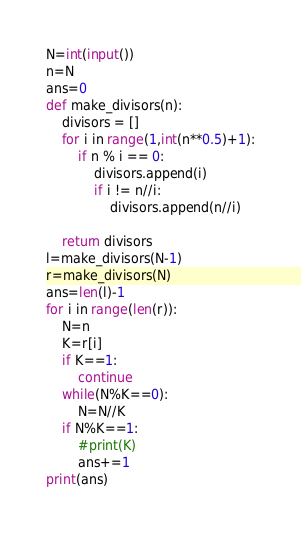Convert code to text. <code><loc_0><loc_0><loc_500><loc_500><_Python_>N=int(input())
n=N
ans=0
def make_divisors(n):
    divisors = []
    for i in range(1,int(n**0.5)+1):
        if n % i == 0:
            divisors.append(i)
            if i != n//i:
                divisors.append(n//i)

    return divisors
l=make_divisors(N-1)
r=make_divisors(N)
ans=len(l)-1
for i in range(len(r)):
    N=n
    K=r[i]
    if K==1:
        continue
    while(N%K==0):
        N=N//K
    if N%K==1:
        #print(K)
        ans+=1
print(ans)</code> 